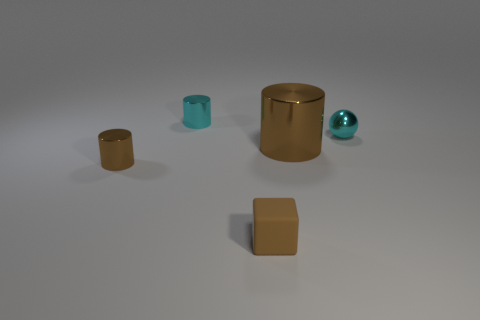Add 2 tiny blue cubes. How many objects exist? 7 Subtract all cylinders. How many objects are left? 2 Add 3 tiny spheres. How many tiny spheres exist? 4 Subtract 0 green cylinders. How many objects are left? 5 Subtract all large brown shiny cylinders. Subtract all small cyan balls. How many objects are left? 3 Add 4 cyan objects. How many cyan objects are left? 6 